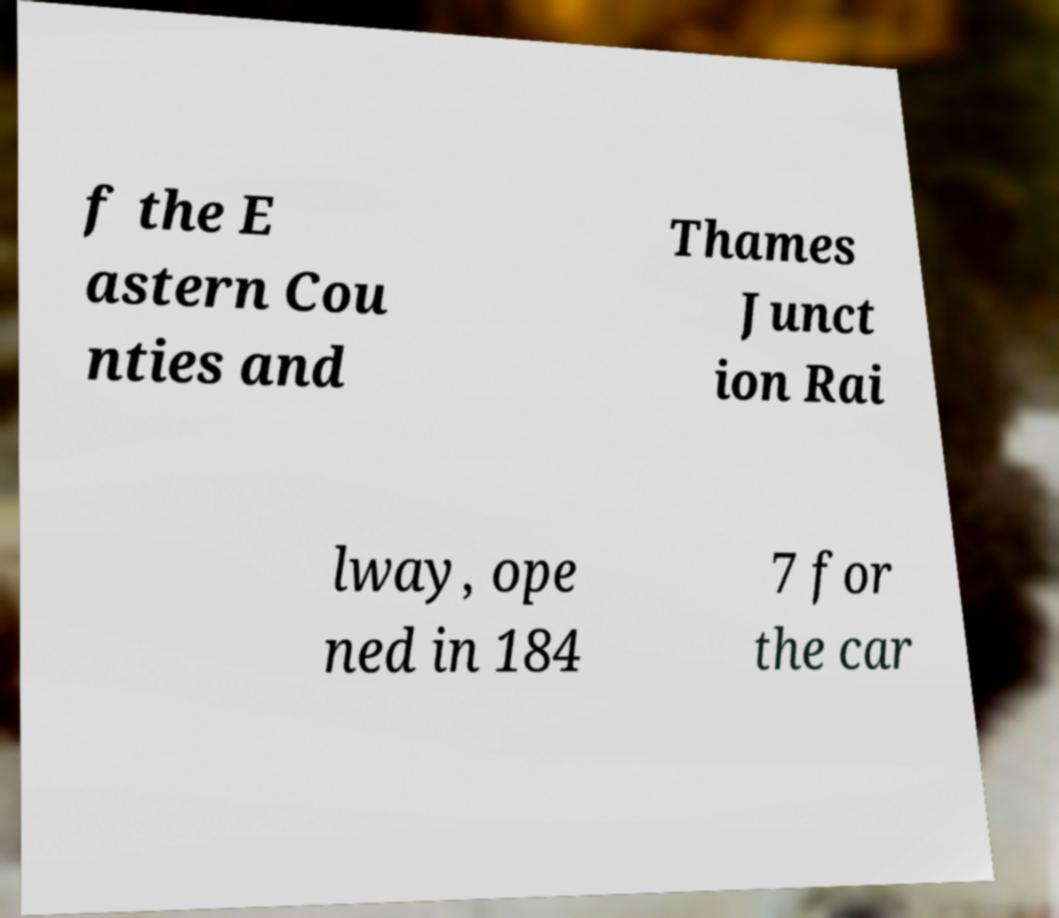Please identify and transcribe the text found in this image. f the E astern Cou nties and Thames Junct ion Rai lway, ope ned in 184 7 for the car 